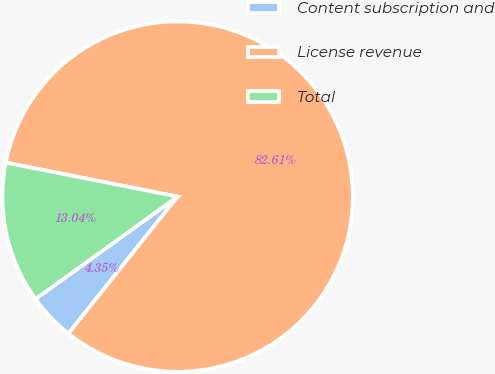Convert chart to OTSL. <chart><loc_0><loc_0><loc_500><loc_500><pie_chart><fcel>Content subscription and<fcel>License revenue<fcel>Total<nl><fcel>4.35%<fcel>82.61%<fcel>13.04%<nl></chart> 